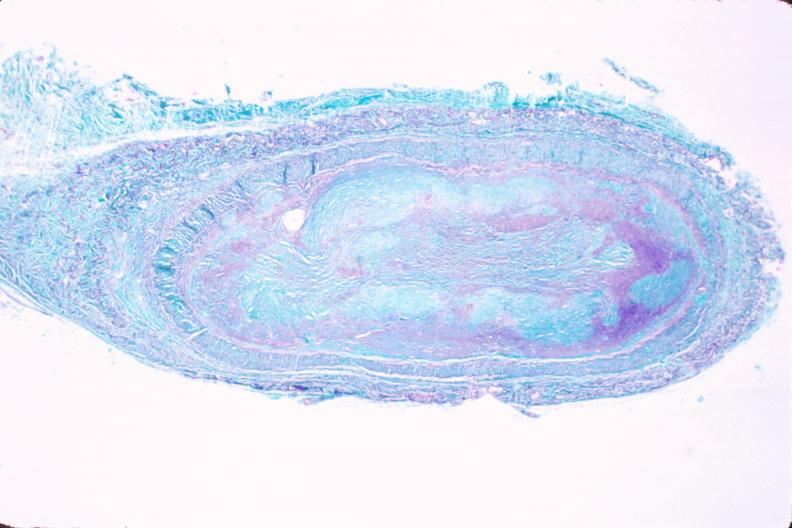does this image show saphenous vein graft sclerosis?
Answer the question using a single word or phrase. Yes 